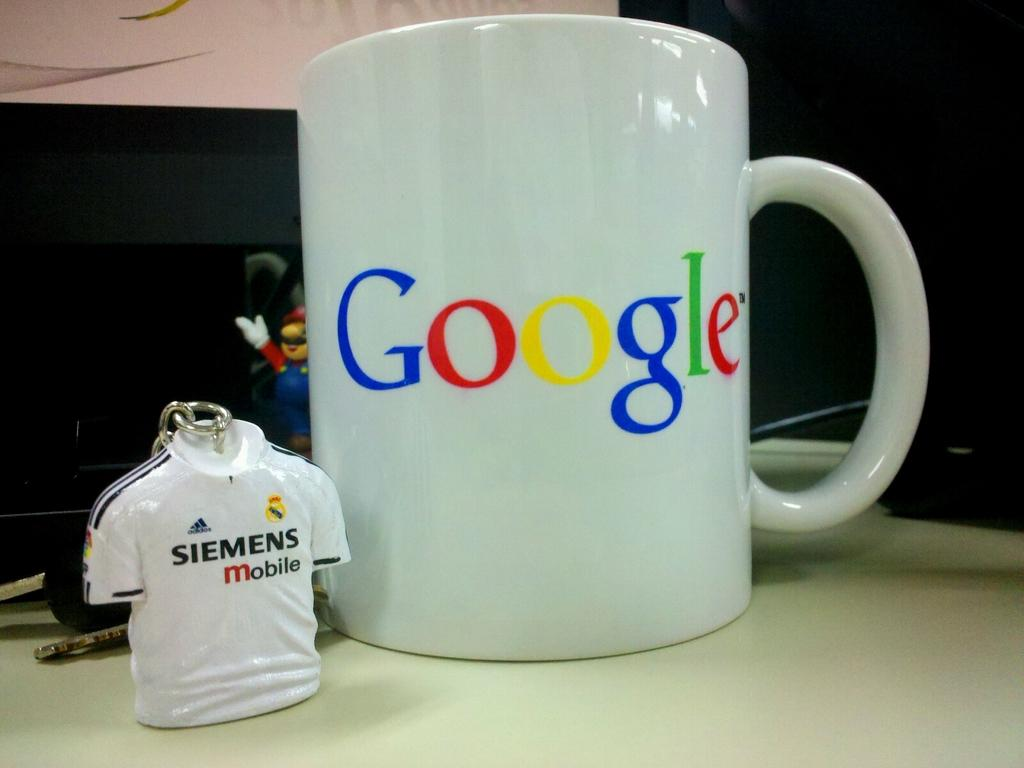<image>
Present a compact description of the photo's key features. Google mug sitting on the counter with Mario and a sports shirt. 